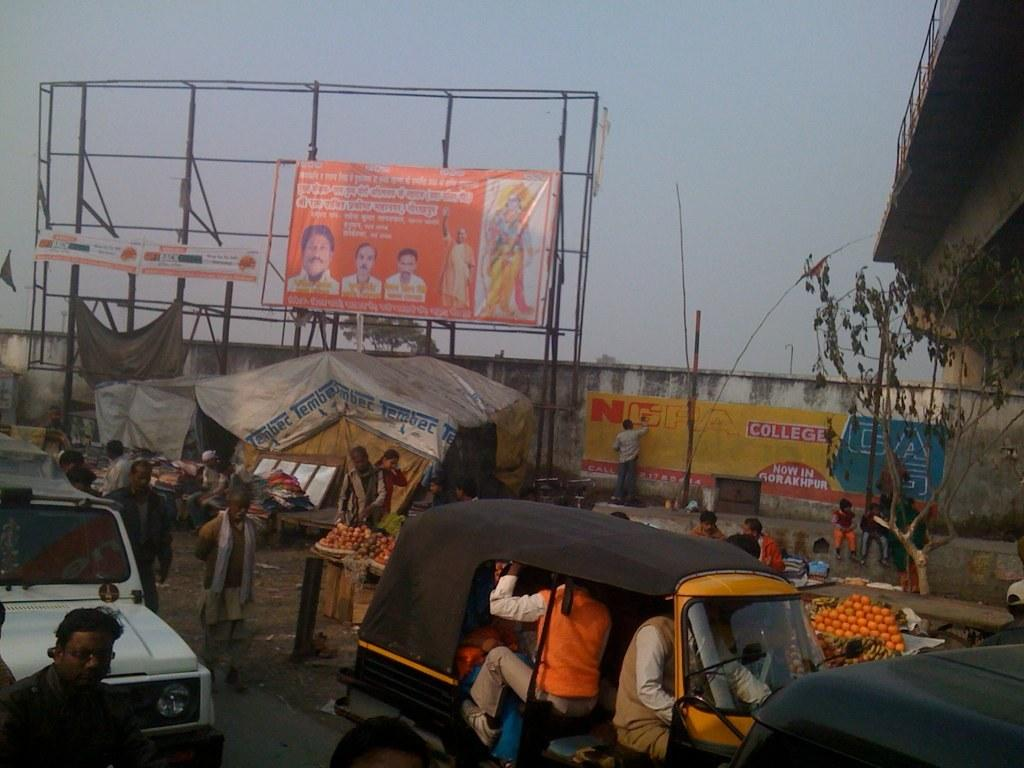<image>
Render a clear and concise summary of the photo. A street scene and against the wall there's a yellow sign that says College. 